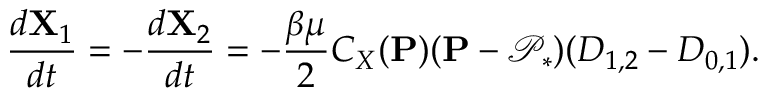Convert formula to latex. <formula><loc_0><loc_0><loc_500><loc_500>\frac { d X _ { 1 } } { d t } = - \frac { d X _ { 2 } } { d t } = - \frac { \beta \mu } { 2 } C _ { X } ( P ) ( P - \mathcal { P } _ { * } ) ( D _ { 1 , 2 } - D _ { 0 , 1 } ) .</formula> 